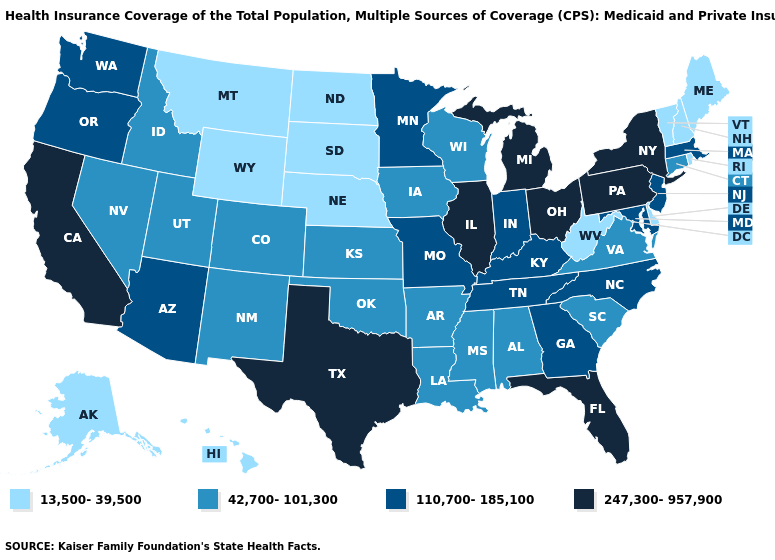What is the highest value in the USA?
Be succinct. 247,300-957,900. Which states have the highest value in the USA?
Short answer required. California, Florida, Illinois, Michigan, New York, Ohio, Pennsylvania, Texas. Among the states that border Utah , does Idaho have the highest value?
Concise answer only. No. Among the states that border Illinois , does Wisconsin have the lowest value?
Answer briefly. Yes. What is the lowest value in states that border South Dakota?
Answer briefly. 13,500-39,500. What is the highest value in the Northeast ?
Answer briefly. 247,300-957,900. Name the states that have a value in the range 110,700-185,100?
Give a very brief answer. Arizona, Georgia, Indiana, Kentucky, Maryland, Massachusetts, Minnesota, Missouri, New Jersey, North Carolina, Oregon, Tennessee, Washington. How many symbols are there in the legend?
Short answer required. 4. Is the legend a continuous bar?
Be succinct. No. What is the value of Montana?
Write a very short answer. 13,500-39,500. Name the states that have a value in the range 42,700-101,300?
Keep it brief. Alabama, Arkansas, Colorado, Connecticut, Idaho, Iowa, Kansas, Louisiana, Mississippi, Nevada, New Mexico, Oklahoma, South Carolina, Utah, Virginia, Wisconsin. Name the states that have a value in the range 42,700-101,300?
Answer briefly. Alabama, Arkansas, Colorado, Connecticut, Idaho, Iowa, Kansas, Louisiana, Mississippi, Nevada, New Mexico, Oklahoma, South Carolina, Utah, Virginia, Wisconsin. Does Minnesota have a lower value than Wyoming?
Keep it brief. No. What is the value of Tennessee?
Answer briefly. 110,700-185,100. Which states have the lowest value in the MidWest?
Keep it brief. Nebraska, North Dakota, South Dakota. 